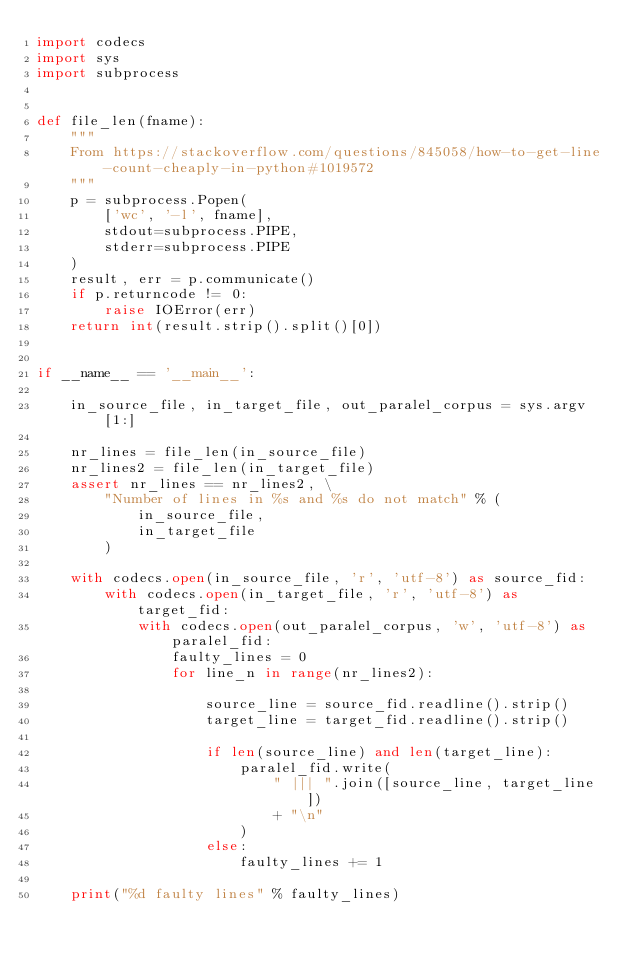<code> <loc_0><loc_0><loc_500><loc_500><_Python_>import codecs
import sys
import subprocess


def file_len(fname):
    """
    From https://stackoverflow.com/questions/845058/how-to-get-line-count-cheaply-in-python#1019572
    """
    p = subprocess.Popen(
        ['wc', '-l', fname],
        stdout=subprocess.PIPE,
        stderr=subprocess.PIPE
    )
    result, err = p.communicate()
    if p.returncode != 0:
        raise IOError(err)
    return int(result.strip().split()[0])


if __name__ == '__main__':

    in_source_file, in_target_file, out_paralel_corpus = sys.argv[1:]

    nr_lines = file_len(in_source_file)
    nr_lines2 = file_len(in_target_file)
    assert nr_lines == nr_lines2, \
        "Number of lines in %s and %s do not match" % (
            in_source_file,
            in_target_file
        )

    with codecs.open(in_source_file, 'r', 'utf-8') as source_fid:
        with codecs.open(in_target_file, 'r', 'utf-8') as target_fid:
            with codecs.open(out_paralel_corpus, 'w', 'utf-8') as paralel_fid:
                faulty_lines = 0
                for line_n in range(nr_lines2):

                    source_line = source_fid.readline().strip()
                    target_line = target_fid.readline().strip()

                    if len(source_line) and len(target_line):
                        paralel_fid.write(
                            " ||| ".join([source_line, target_line])
                            + "\n"
                        )
                    else:
                        faulty_lines += 1

    print("%d faulty lines" % faulty_lines)
</code> 